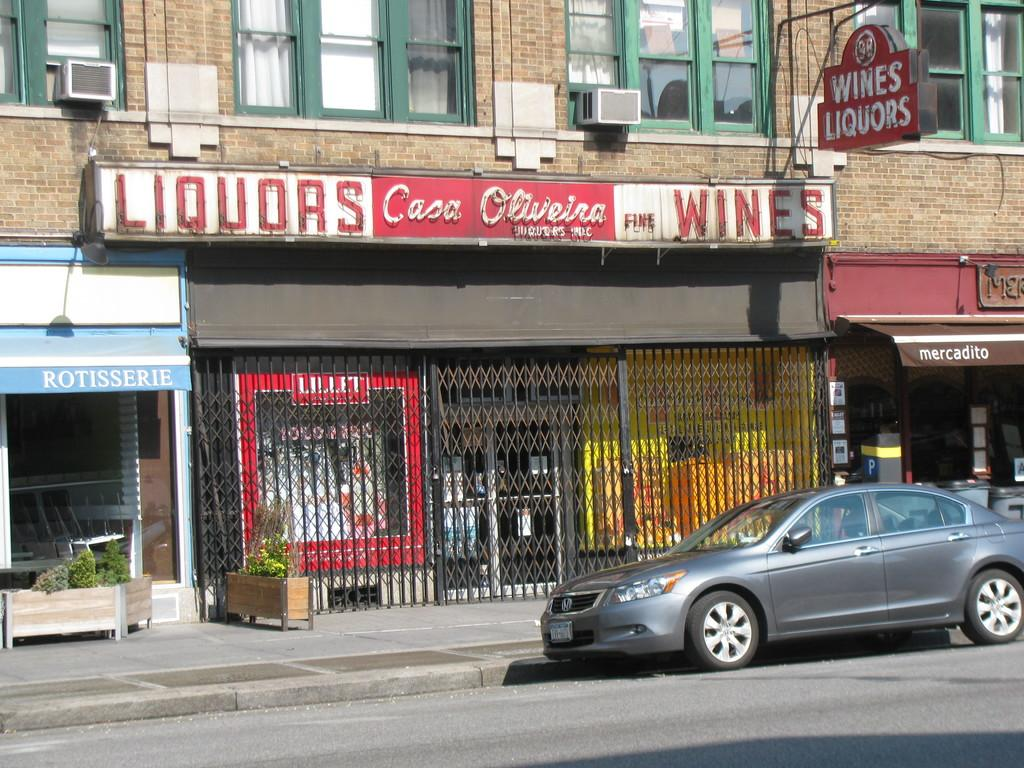What is the main subject of the image? There is a car on the road in the image. What else can be seen in the background of the image? There are buildings visible in the image. Are there any decorative elements in the image? Yes, there are flower pots in the image. What type of nerve can be seen in the image? There is no nerve present in the image. What kind of plants are growing in the flower pots in the image? The image does not show the specific type of plants growing in the flower pots. 